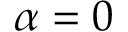Convert formula to latex. <formula><loc_0><loc_0><loc_500><loc_500>\alpha = 0</formula> 